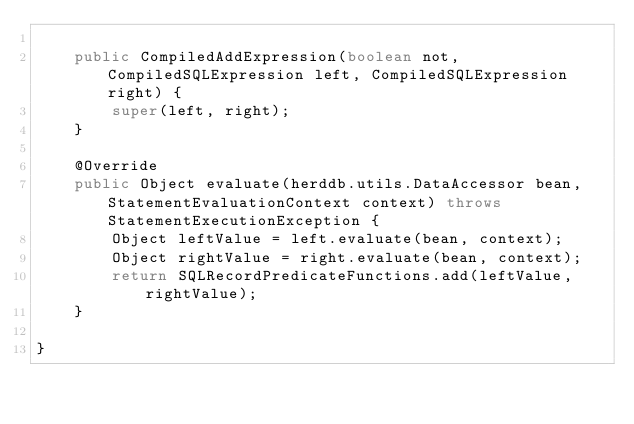<code> <loc_0><loc_0><loc_500><loc_500><_Java_>
    public CompiledAddExpression(boolean not, CompiledSQLExpression left, CompiledSQLExpression right) {
        super(left, right);
    }

    @Override
    public Object evaluate(herddb.utils.DataAccessor bean, StatementEvaluationContext context) throws StatementExecutionException {
        Object leftValue = left.evaluate(bean, context);
        Object rightValue = right.evaluate(bean, context);
        return SQLRecordPredicateFunctions.add(leftValue, rightValue);
    }

}
</code> 